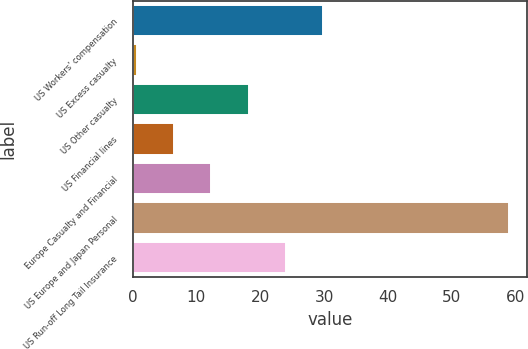<chart> <loc_0><loc_0><loc_500><loc_500><bar_chart><fcel>US Workers' compensation<fcel>US Excess casualty<fcel>US Other casualty<fcel>US Financial lines<fcel>Europe Casualty and Financial<fcel>US Europe and Japan Personal<fcel>US Run-off Long Tail Insurance<nl><fcel>29.8<fcel>0.7<fcel>18.16<fcel>6.52<fcel>12.34<fcel>58.9<fcel>23.98<nl></chart> 